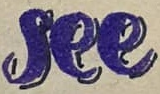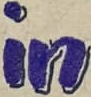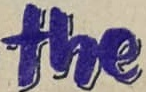What words can you see in these images in sequence, separated by a semicolon? see; in; the 